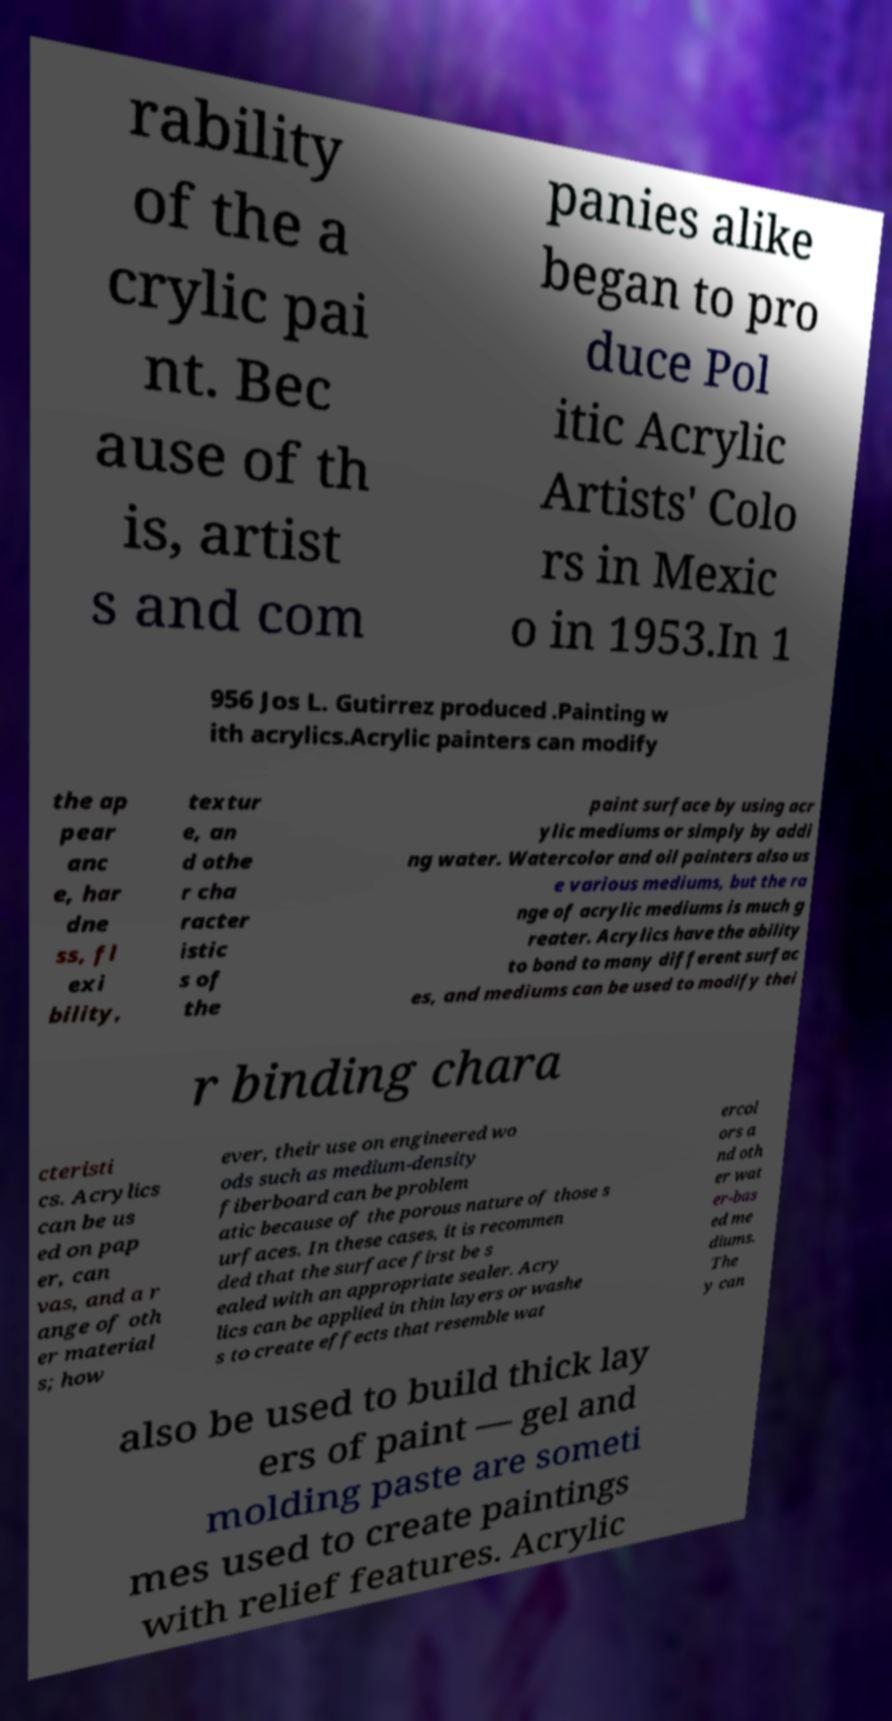What messages or text are displayed in this image? I need them in a readable, typed format. rability of the a crylic pai nt. Bec ause of th is, artist s and com panies alike began to pro duce Pol itic Acrylic Artists' Colo rs in Mexic o in 1953.In 1 956 Jos L. Gutirrez produced .Painting w ith acrylics.Acrylic painters can modify the ap pear anc e, har dne ss, fl exi bility, textur e, an d othe r cha racter istic s of the paint surface by using acr ylic mediums or simply by addi ng water. Watercolor and oil painters also us e various mediums, but the ra nge of acrylic mediums is much g reater. Acrylics have the ability to bond to many different surfac es, and mediums can be used to modify thei r binding chara cteristi cs. Acrylics can be us ed on pap er, can vas, and a r ange of oth er material s; how ever, their use on engineered wo ods such as medium-density fiberboard can be problem atic because of the porous nature of those s urfaces. In these cases, it is recommen ded that the surface first be s ealed with an appropriate sealer. Acry lics can be applied in thin layers or washe s to create effects that resemble wat ercol ors a nd oth er wat er-bas ed me diums. The y can also be used to build thick lay ers of paint — gel and molding paste are someti mes used to create paintings with relief features. Acrylic 